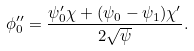Convert formula to latex. <formula><loc_0><loc_0><loc_500><loc_500>\phi ^ { \prime \prime } _ { 0 } = \frac { \psi _ { 0 } ^ { \prime } \chi + ( \psi _ { 0 } - \psi _ { 1 } ) \chi ^ { \prime } } { 2 \sqrt { \psi } } .</formula> 